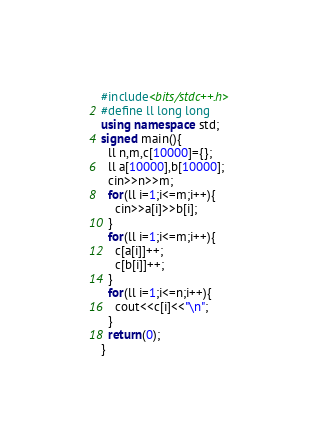Convert code to text. <code><loc_0><loc_0><loc_500><loc_500><_C++_>#include<bits/stdc++.h>
#define ll long long
using namespace std;
signed main(){
  ll n,m,c[10000]={};
  ll a[10000],b[10000];
  cin>>n>>m;
  for(ll i=1;i<=m;i++){
    cin>>a[i]>>b[i];
  }
  for(ll i=1;i<=m;i++){
    c[a[i]]++;
    c[b[i]]++;
  }
  for(ll i=1;i<=n;i++){
    cout<<c[i]<<"\n";
  }
  return(0);
}
</code> 